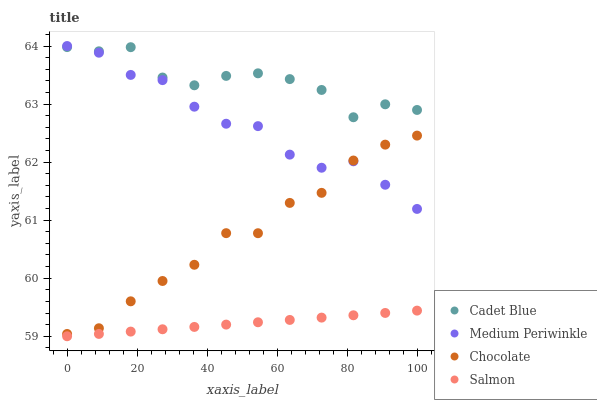Does Salmon have the minimum area under the curve?
Answer yes or no. Yes. Does Cadet Blue have the maximum area under the curve?
Answer yes or no. Yes. Does Medium Periwinkle have the minimum area under the curve?
Answer yes or no. No. Does Medium Periwinkle have the maximum area under the curve?
Answer yes or no. No. Is Salmon the smoothest?
Answer yes or no. Yes. Is Cadet Blue the roughest?
Answer yes or no. Yes. Is Medium Periwinkle the smoothest?
Answer yes or no. No. Is Medium Periwinkle the roughest?
Answer yes or no. No. Does Salmon have the lowest value?
Answer yes or no. Yes. Does Medium Periwinkle have the lowest value?
Answer yes or no. No. Does Medium Periwinkle have the highest value?
Answer yes or no. Yes. Does Cadet Blue have the highest value?
Answer yes or no. No. Is Salmon less than Cadet Blue?
Answer yes or no. Yes. Is Cadet Blue greater than Salmon?
Answer yes or no. Yes. Does Medium Periwinkle intersect Cadet Blue?
Answer yes or no. Yes. Is Medium Periwinkle less than Cadet Blue?
Answer yes or no. No. Is Medium Periwinkle greater than Cadet Blue?
Answer yes or no. No. Does Salmon intersect Cadet Blue?
Answer yes or no. No. 